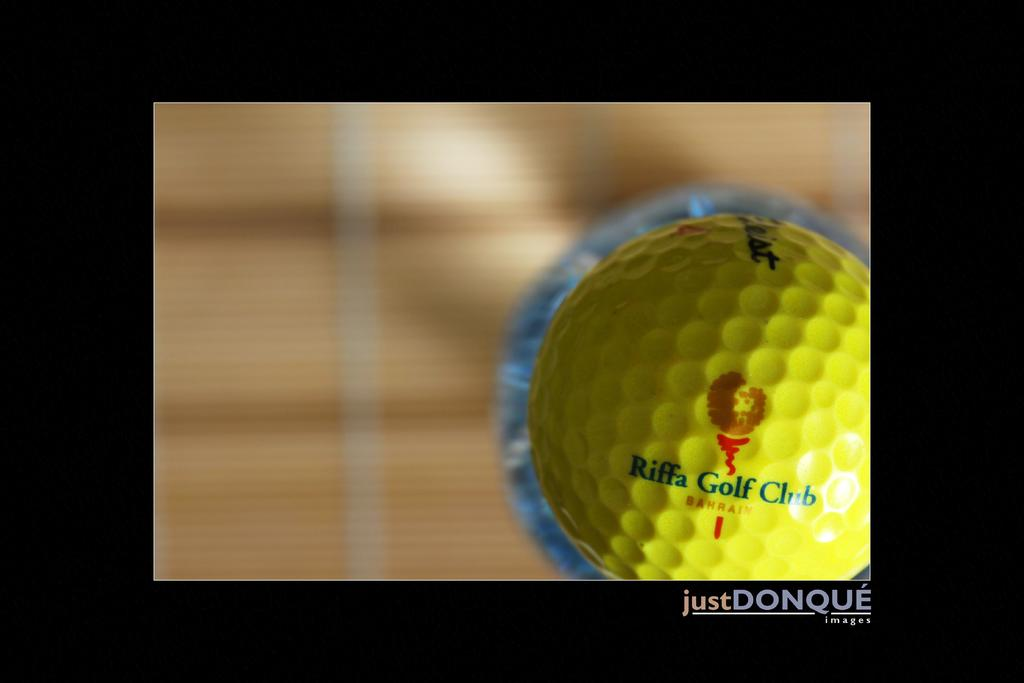What object is the main focus of the image? There is a golf ball in the image. What color is the golf ball? The golf ball is yellow. Can you describe the background of the image? The background of the image is blurred. Where is the soap located in the image? There is no soap present in the image. What type of action is taking place in the image? The image does not depict any specific action; it simply shows a yellow golf ball with a blurred background. 